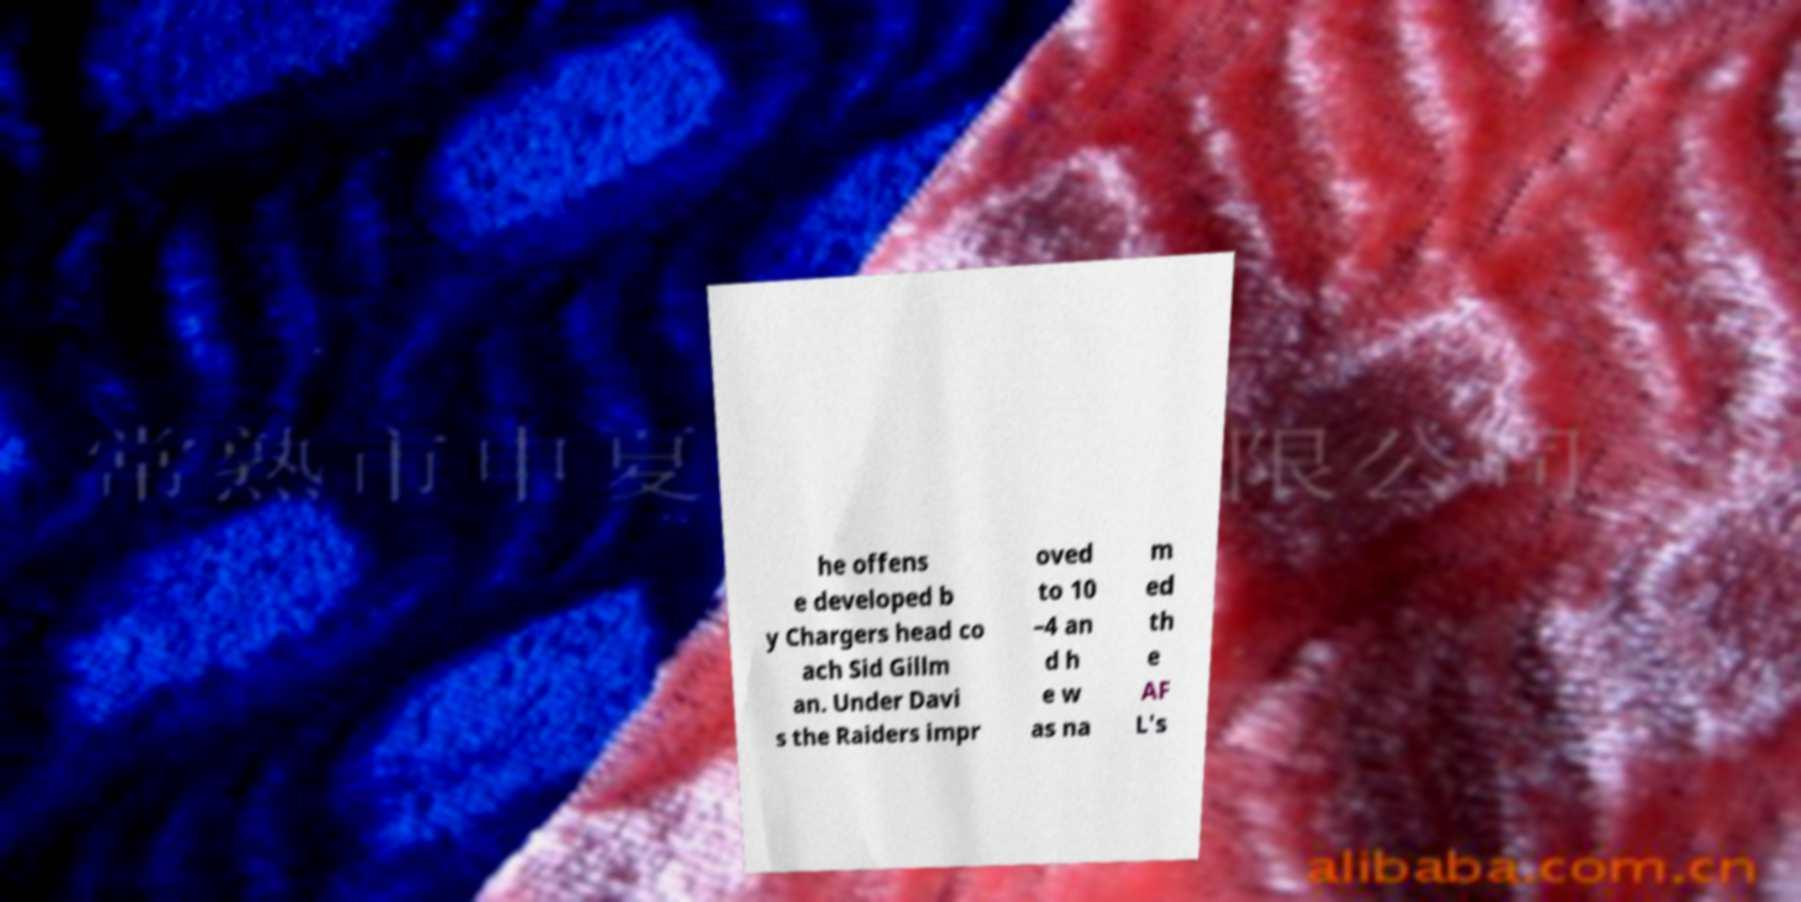Can you accurately transcribe the text from the provided image for me? he offens e developed b y Chargers head co ach Sid Gillm an. Under Davi s the Raiders impr oved to 10 –4 an d h e w as na m ed th e AF L's 